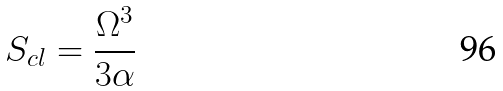Convert formula to latex. <formula><loc_0><loc_0><loc_500><loc_500>S _ { c l } = \frac { \Omega ^ { 3 } } { 3 \alpha }</formula> 